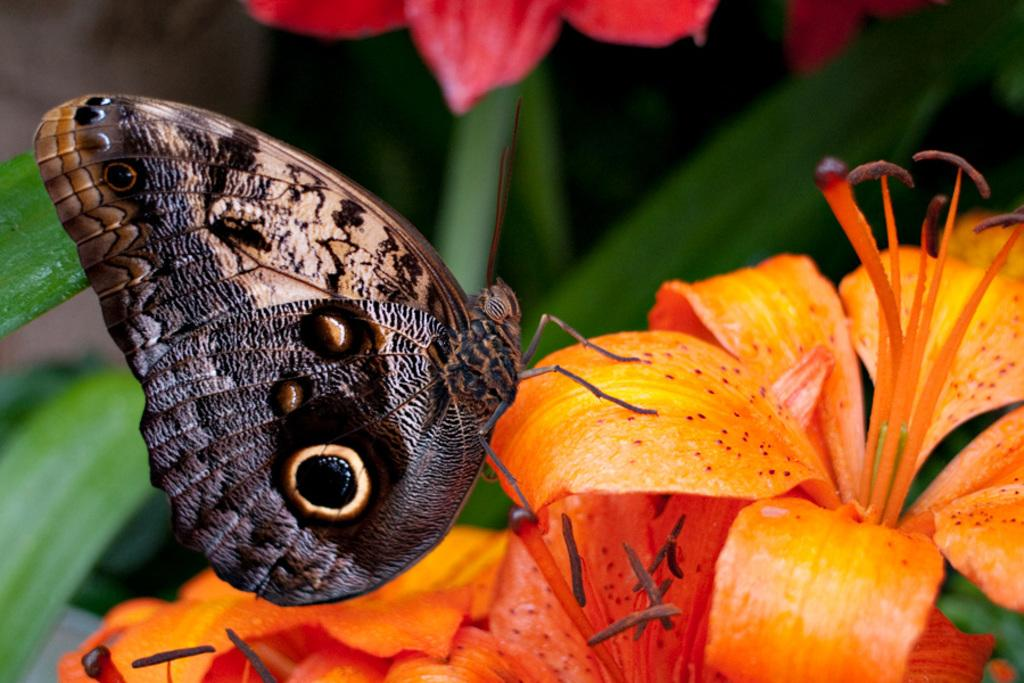What type of insect is present in the image? There is a butterfly in the image. What is the color of the butterfly? The butterfly is yellow or orange in color. What other natural elements can be seen in the image? There are flowers and leaves in the image. What is the color of the flowers? The flowers are yellow or orange in color. How would you describe the background of the image? The background of the image is slightly blurred. How many feathers are attached to the snake in the image? There is no snake present in the image, and therefore no feathers can be observed. 